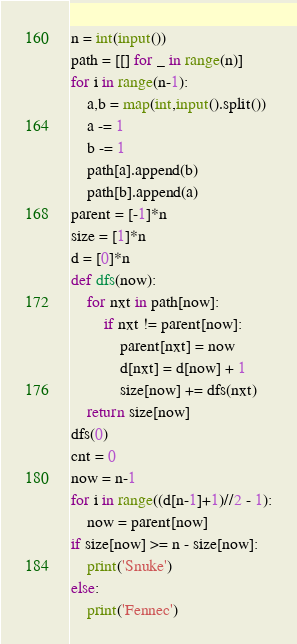<code> <loc_0><loc_0><loc_500><loc_500><_Python_>n = int(input())
path = [[] for _ in range(n)]
for i in range(n-1):
    a,b = map(int,input().split())
    a -= 1
    b -= 1
    path[a].append(b)
    path[b].append(a)
parent = [-1]*n
size = [1]*n
d = [0]*n
def dfs(now):
    for nxt in path[now]:
        if nxt != parent[now]:
            parent[nxt] = now
            d[nxt] = d[now] + 1
            size[now] += dfs(nxt)
    return size[now]
dfs(0)
cnt = 0
now = n-1
for i in range((d[n-1]+1)//2 - 1):
    now = parent[now]
if size[now] >= n - size[now]:
    print('Snuke')
else:
    print('Fennec')
</code> 